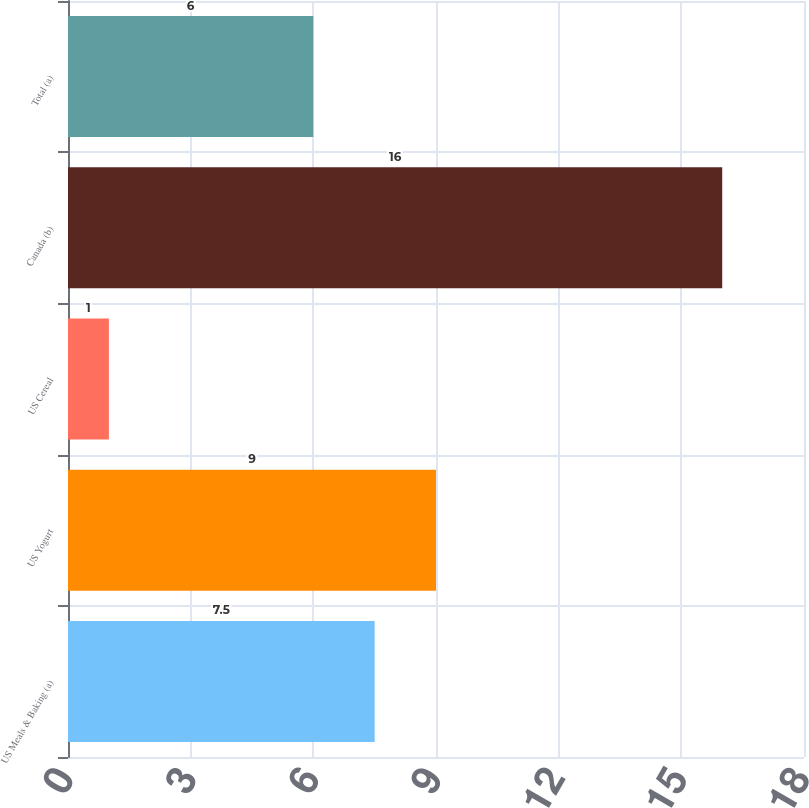Convert chart to OTSL. <chart><loc_0><loc_0><loc_500><loc_500><bar_chart><fcel>US Meals & Baking (a)<fcel>US Yogurt<fcel>US Cereal<fcel>Canada (b)<fcel>Total (a)<nl><fcel>7.5<fcel>9<fcel>1<fcel>16<fcel>6<nl></chart> 